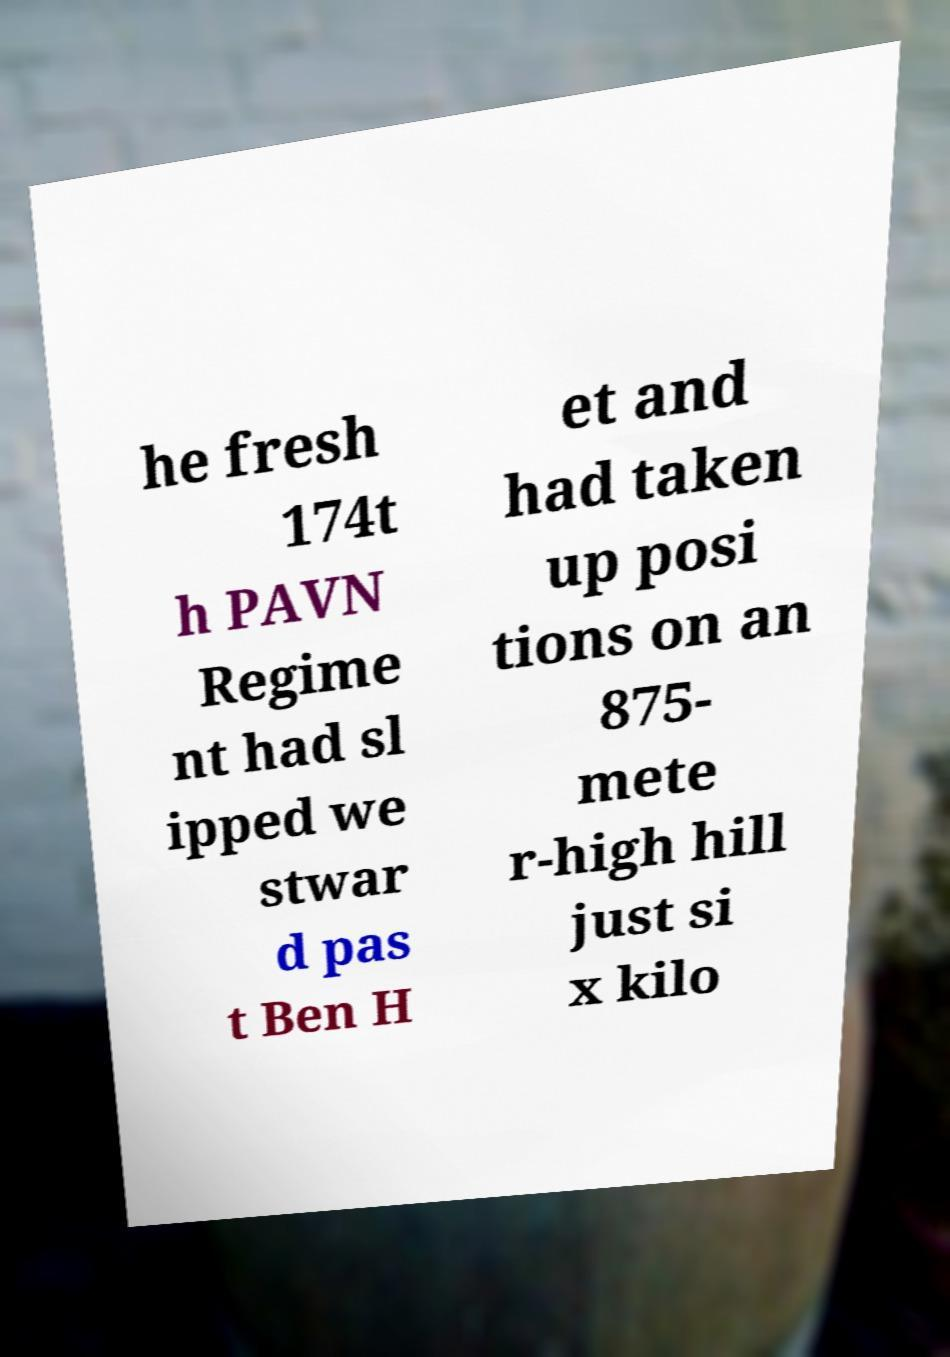Can you accurately transcribe the text from the provided image for me? he fresh 174t h PAVN Regime nt had sl ipped we stwar d pas t Ben H et and had taken up posi tions on an 875- mete r-high hill just si x kilo 